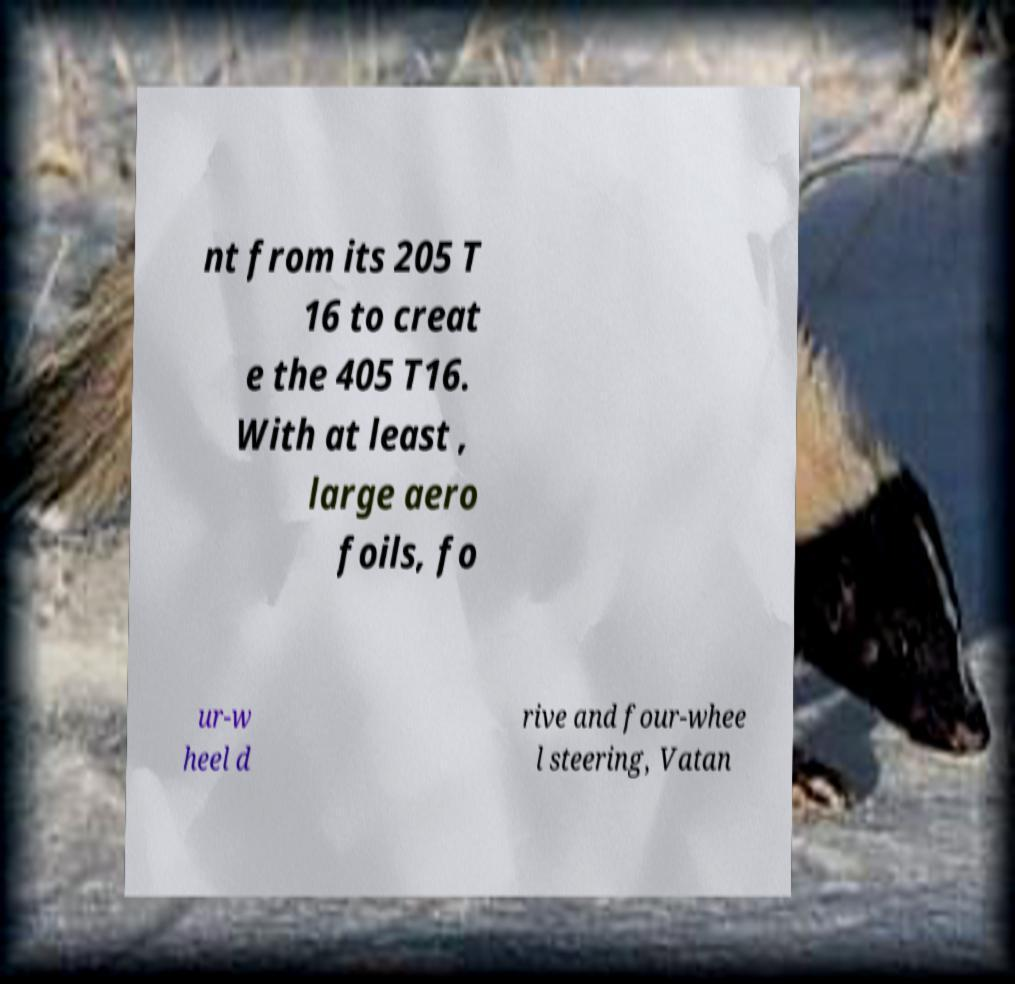For documentation purposes, I need the text within this image transcribed. Could you provide that? nt from its 205 T 16 to creat e the 405 T16. With at least , large aero foils, fo ur-w heel d rive and four-whee l steering, Vatan 